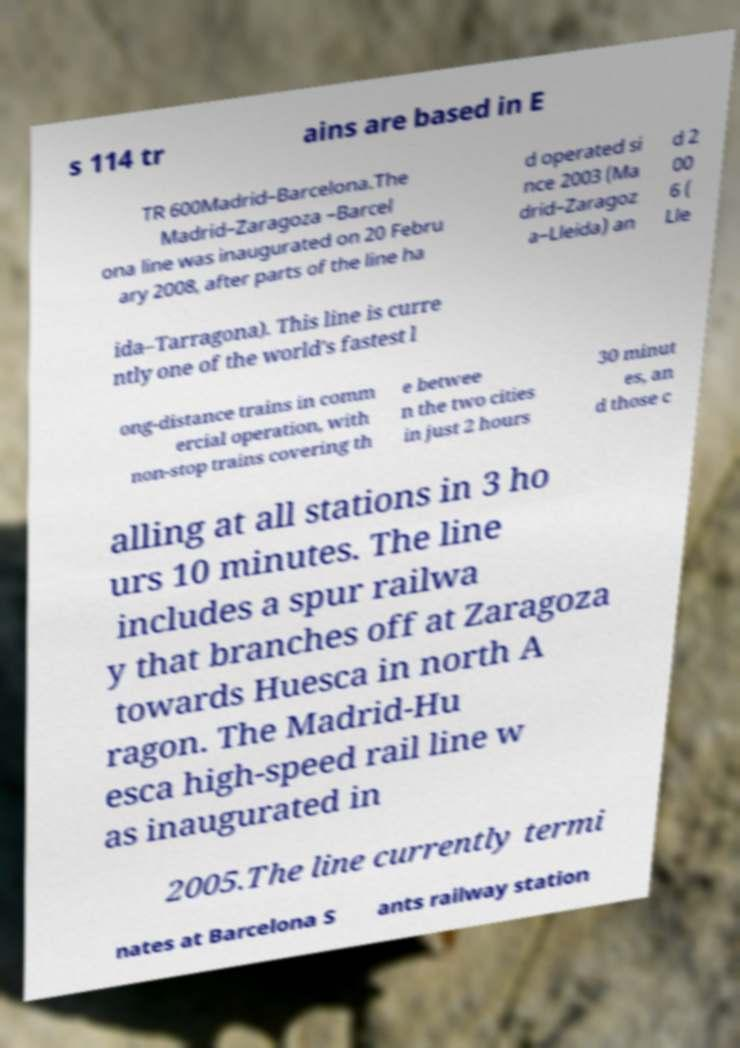Could you assist in decoding the text presented in this image and type it out clearly? s 114 tr ains are based in E TR 600Madrid–Barcelona.The Madrid–Zaragoza –Barcel ona line was inaugurated on 20 Febru ary 2008, after parts of the line ha d operated si nce 2003 (Ma drid–Zaragoz a–Lleida) an d 2 00 6 ( Lle ida–Tarragona). This line is curre ntly one of the world's fastest l ong-distance trains in comm ercial operation, with non-stop trains covering th e betwee n the two cities in just 2 hours 30 minut es, an d those c alling at all stations in 3 ho urs 10 minutes. The line includes a spur railwa y that branches off at Zaragoza towards Huesca in north A ragon. The Madrid-Hu esca high-speed rail line w as inaugurated in 2005.The line currently termi nates at Barcelona S ants railway station 